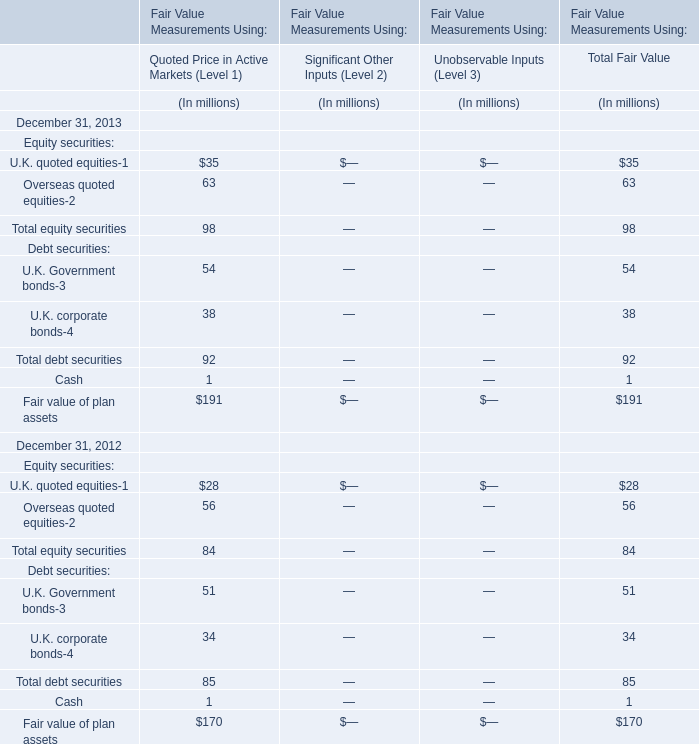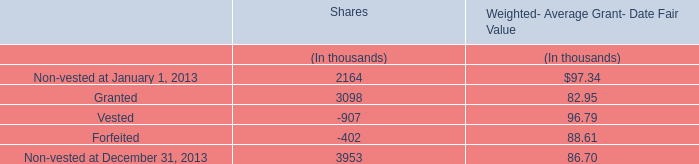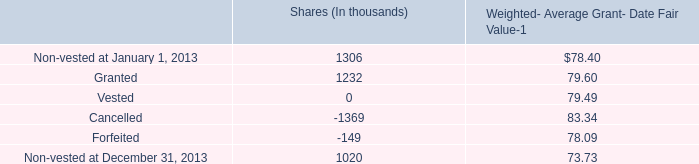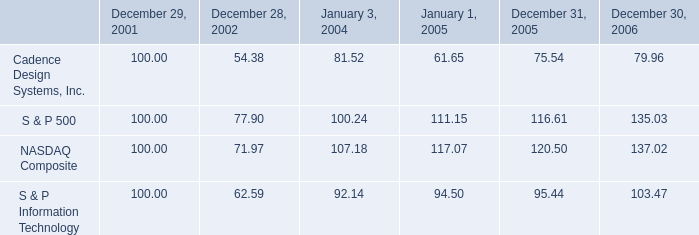What's the growth rate of U.K. quoted equities in Quoted Price in Active Markets (Level 1) in 2013? 
Computations: ((35 - 28) / 28)
Answer: 0.25. 